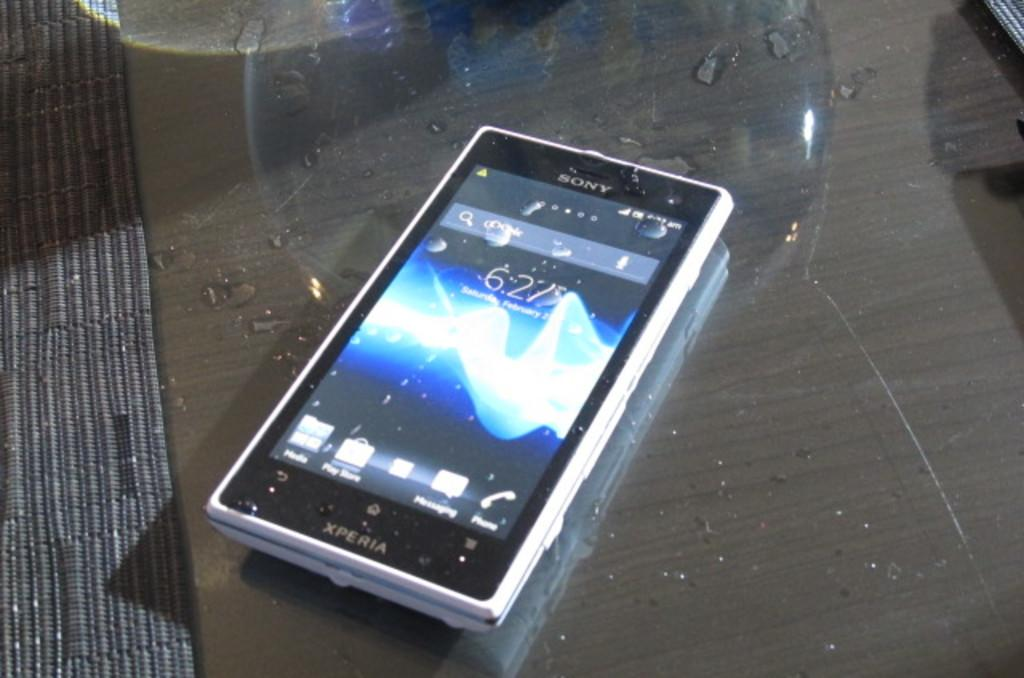Provide a one-sentence caption for the provided image. A dirty Xperia cellphone sits on a glass table. 